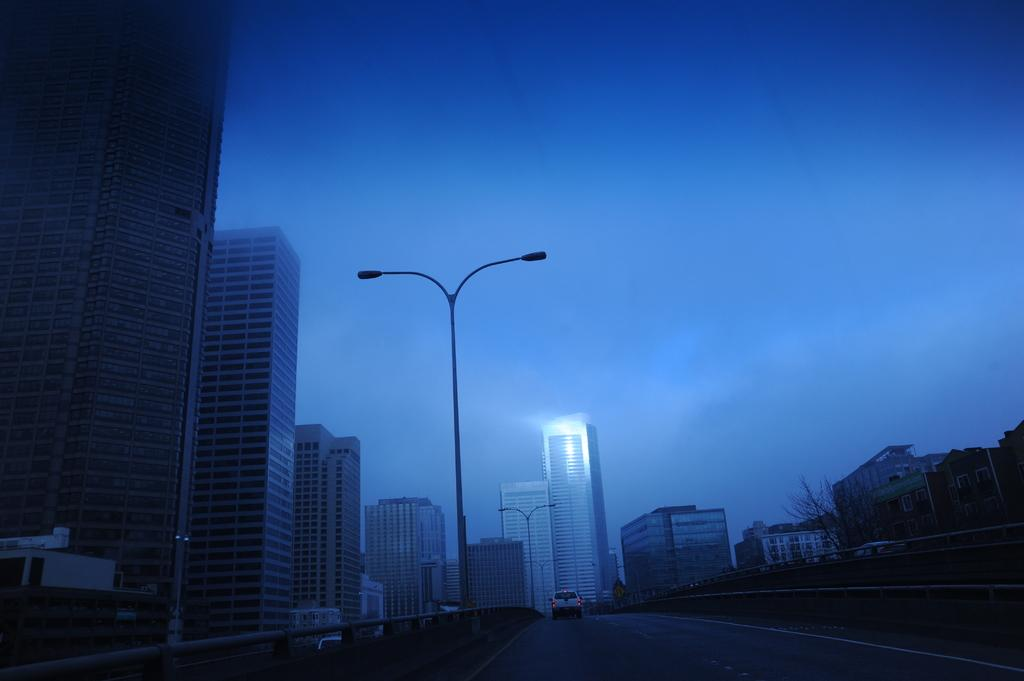What is the main subject of the image? There is a car on the road in the image. What can be seen alongside the road in the image? There is a fence in the image. What type of structures are present near the car? There are lights on poles in the image. What natural element is visible in the image? There is a tree in the image. What can be seen in the distance in the image? There are buildings visible in the background of the image. What is the color of the sky in the background of the image? The sky is blue in the background of the image. What type of agreement is being signed by the car in the image? There is no agreement being signed in the image; it is a photograph of a car on the road. What does the car in the image believe about the current situation? The car in the image is an inanimate object and does not have beliefs or thoughts. 